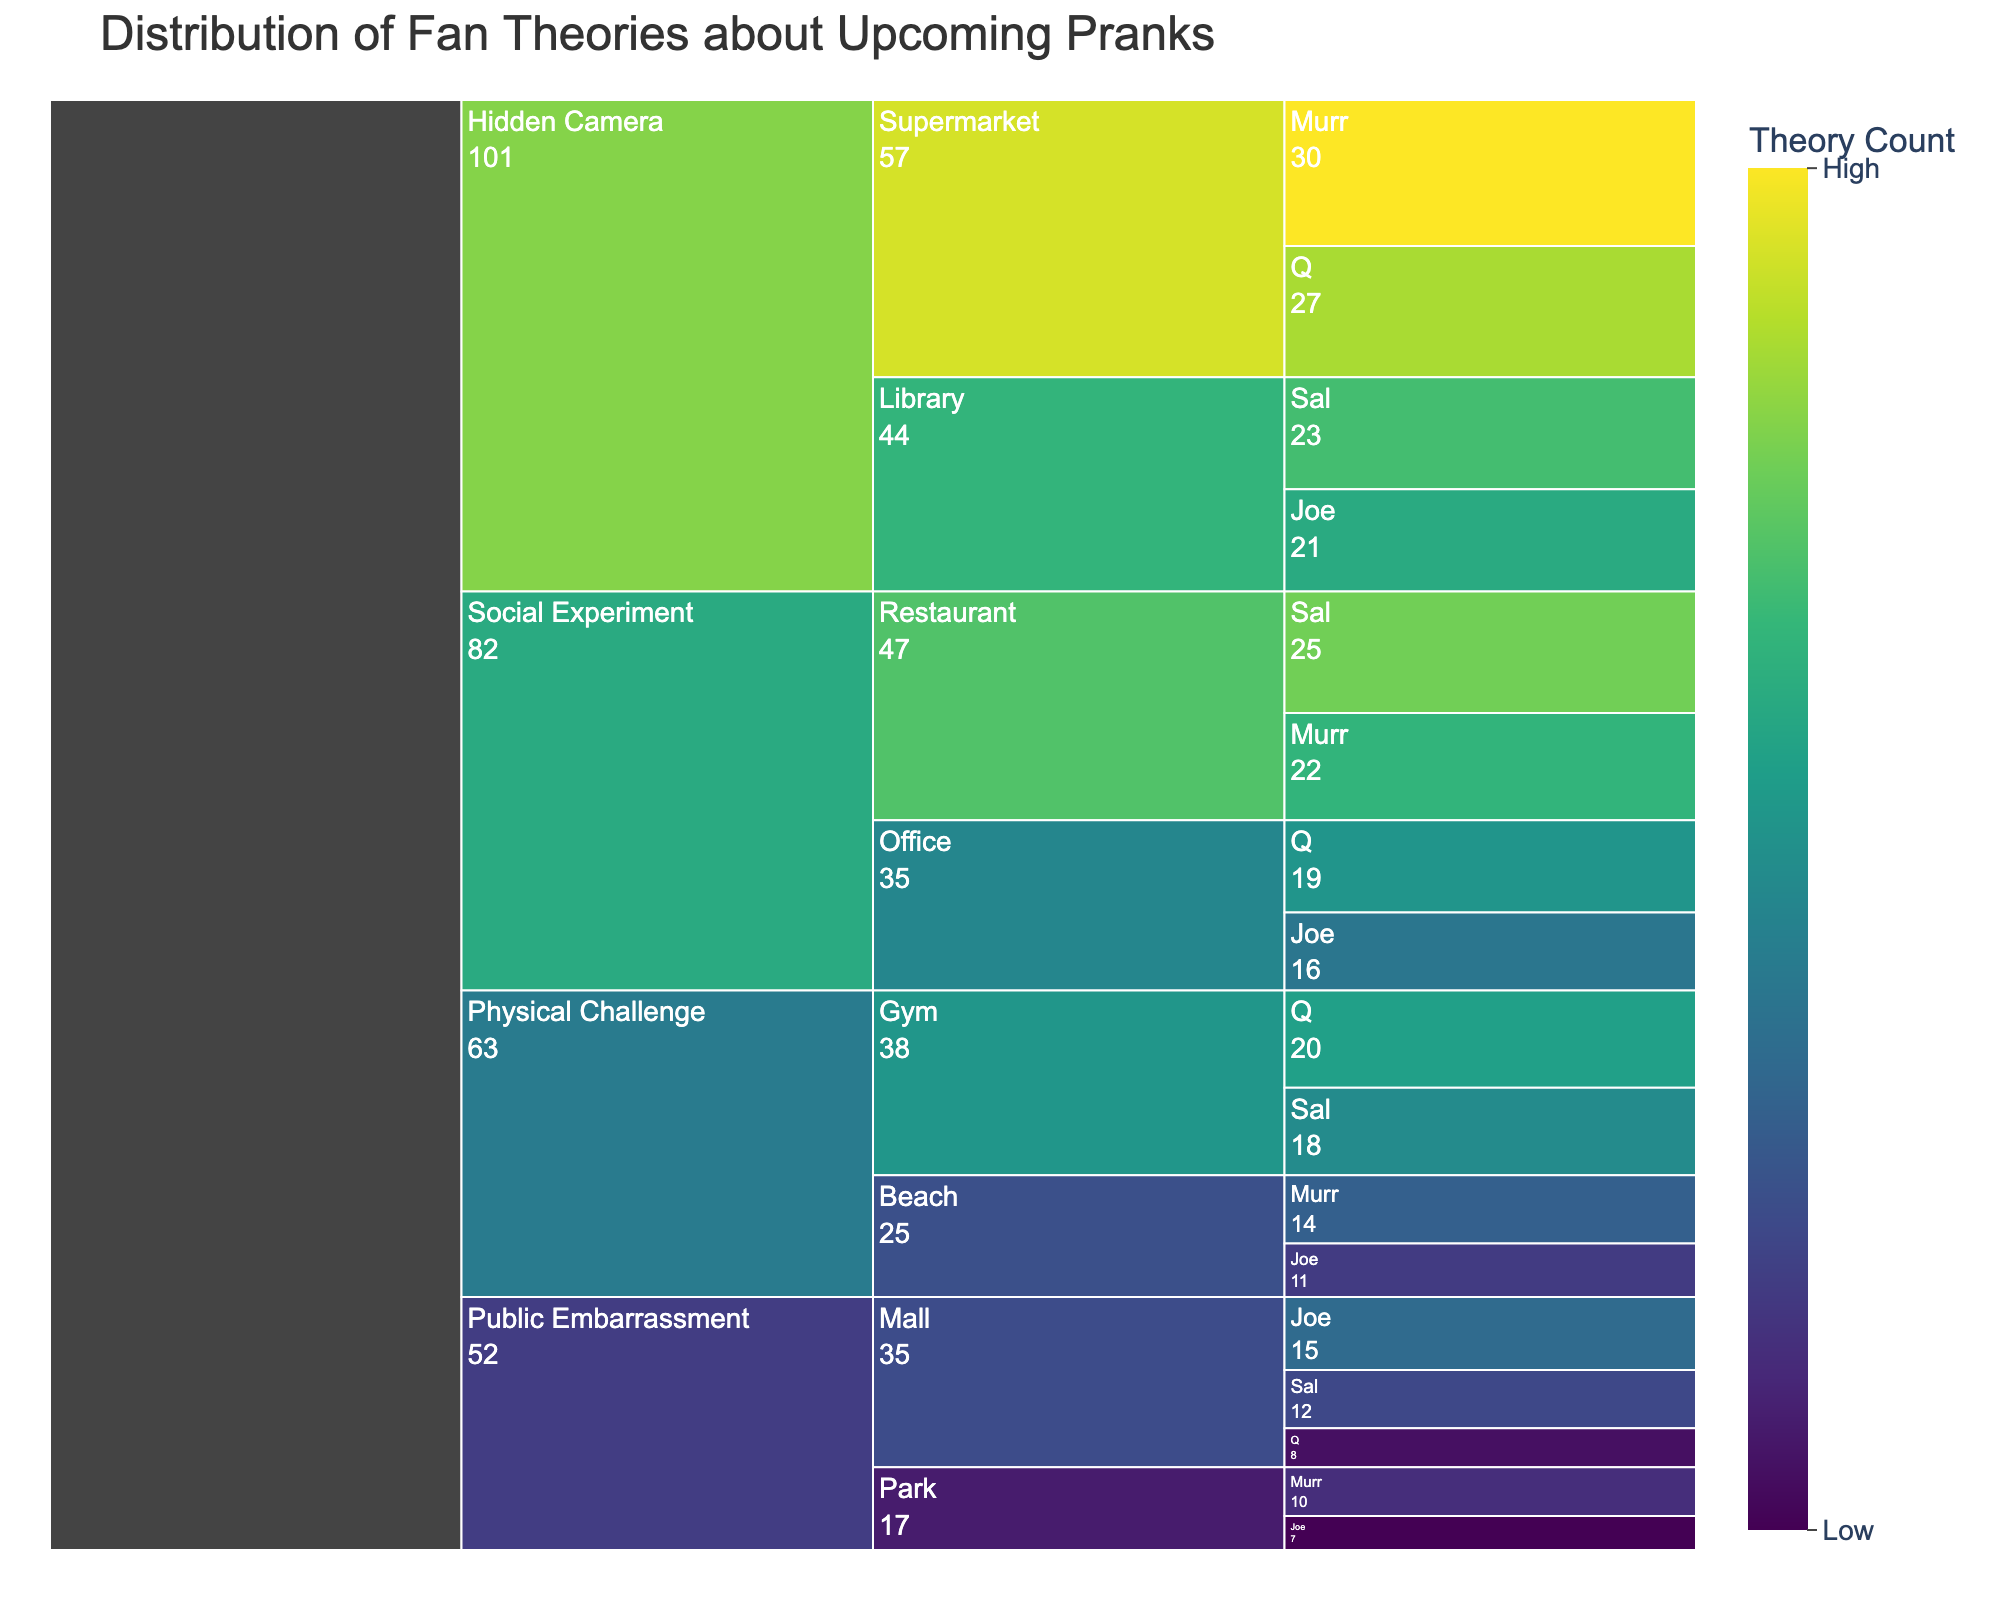what is the title of the figure? The title of the figure is displayed at the top and provides an overview of the data being visualized. It's usually the largest text in the plot, helping interpret the data context before diving into details.
Answer: Distribution of Fan Theories about Upcoming Pranks Which category has the highest total theory count? The icicle chart displays aggregated theory counts for each category along the hierarchy. By looking at the size or value at the root node (prank type), you can determine which category has the largest total.
Answer: Hidden Camera How many theories predict Joe's involvement in Gym-related pranks? Navigate to the respective prank type and location within the icicle chart, then find and sum the theory counts where Joe is involved. Since Joe is not listed under Gym-Physical Challenge theories, no theories predict his involvement there.
Answer: 0 Compare the total theory counts between Library-Hidden Camera and Beach-Physical Challenge categories. Which one is higher and by how much? Sum up the theory counts of all jokers for Library-Hidden Camera (Sal: 23, Joe: 21) and Beach-Physical Challenge (Murr: 14, Joe: 11), then compare the totals. Library-Hidden Camera total (23 + 21 = 44) is higher than Beach-Physical Challenge total (14 + 11 = 25), and the difference is 19.
Answer: Library-Hidden Camera by 19 Which location has the most diverse joker involvement across all prank types? Identify the location where theory distributions are spread across multiple jokers with relatively even counts. Supermarket for Hidden Camera has balanced contributions from Murr (30) and Q (27), indicating diversity.
Answer: Supermarket Which joker appears the most in the top two fan theory counts in all prank types combined? Identify the highest and second-highest theory counts among all jokers across all prank types, then see which joker appears most frequently in these top counts. Murr in Supermarket-Hidden Camera (30) and Sal in Restaurant-Social Experiment (25) each appear once in the top two, but their total values should be summed to find the top joker overall, showing Murr appears in higher positions.
Answer: Murr What’s the difference between the highest and lowest single theory count among prank types? Identify the largest and smallest theory counts in the icicle chart for comparison. The highest single theory count is Murr in Supermarket-Hidden Camera (30), lowest single counts include Q and Joe in the Mall-Public Embarrassment (8 and 7 respectively), with the largest difference being 23.
Answer: 23 